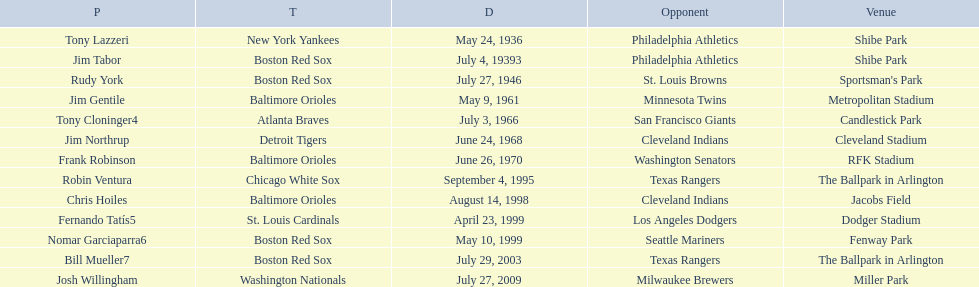What venue did detroit play cleveland in? Cleveland Stadium. Who was the player? Jim Northrup. What date did they play? June 24, 1968. 